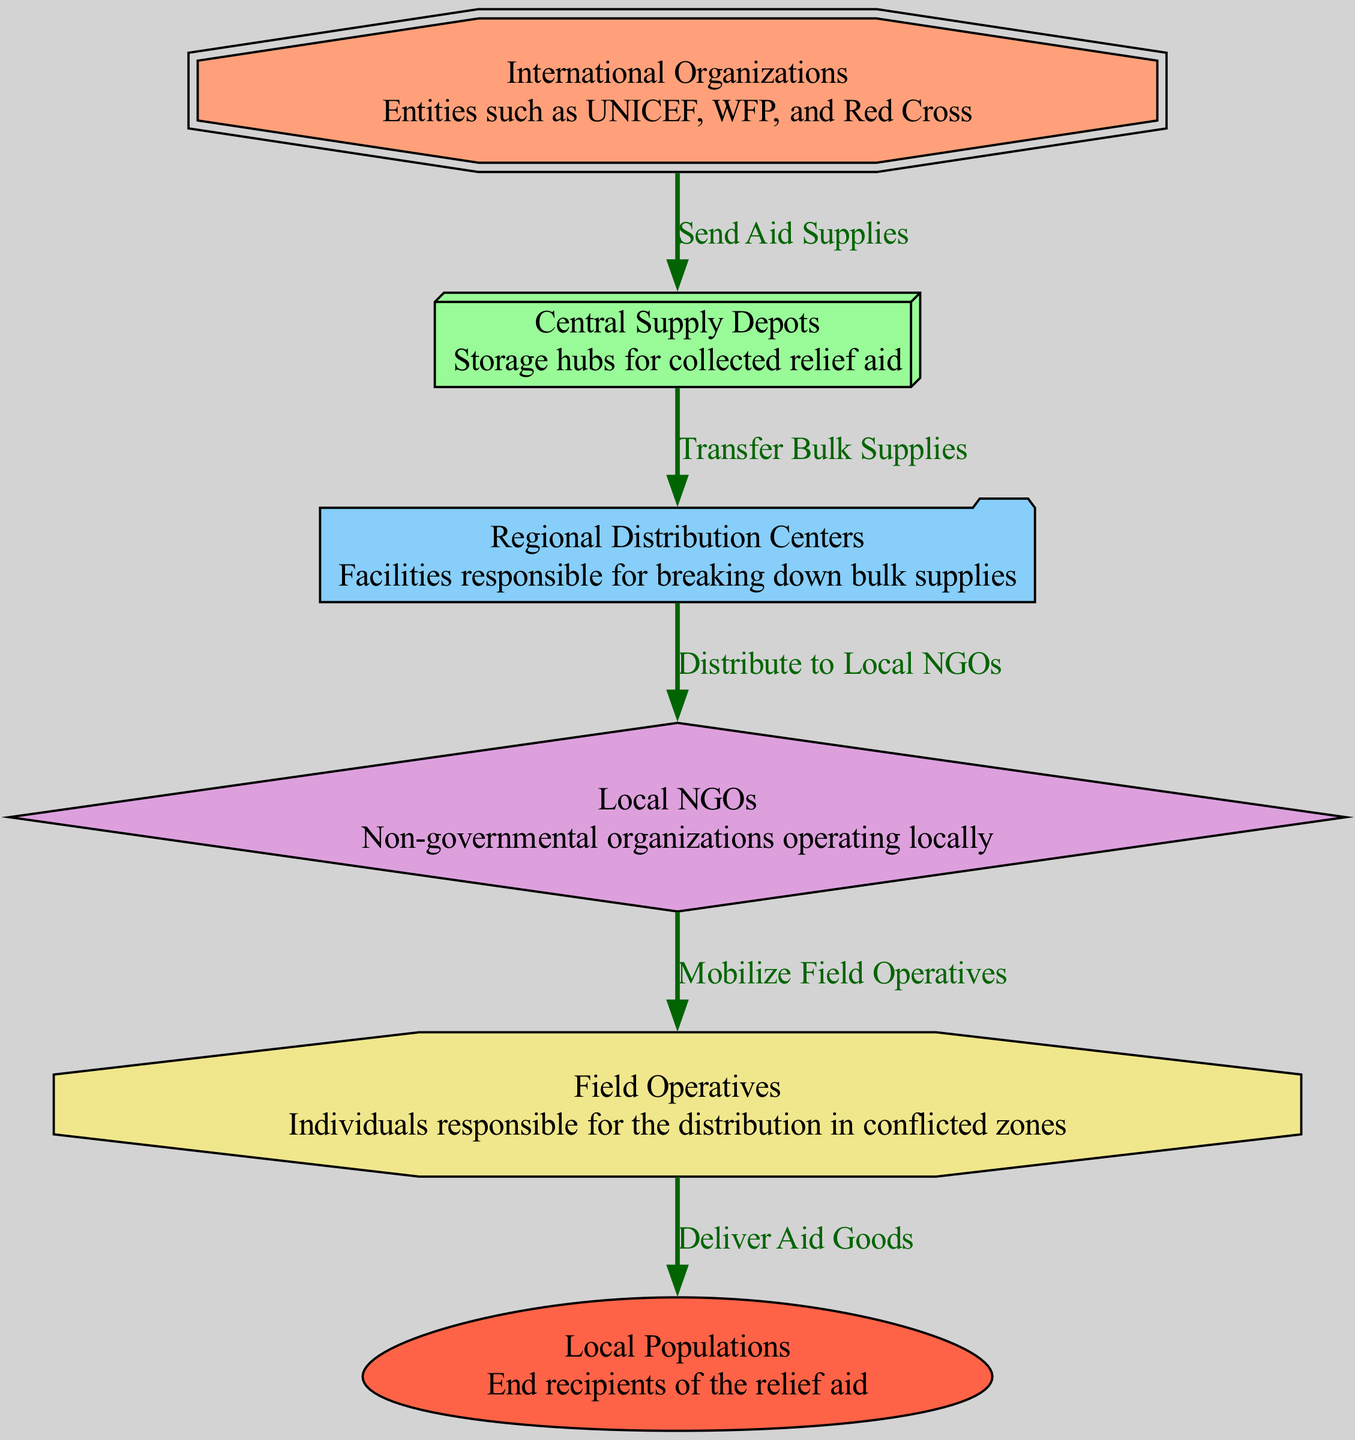What is the starting point for distributing relief aid? The starting point for distributing relief aid is the "International Organizations" node, which indicates where aid supplies are sent from.
Answer: International Organizations How many nodes are present in the diagram? To find the number of nodes, we can count each distinct node listed in the 'nodes' section. In total, there are six nodes identified.
Answer: 6 What is the purpose of Central Supply Depots? The purpose of the "Central Supply Depots" node is to serve as storage hubs for the collected relief aid before it is redistributed.
Answer: Storage hubs for collected relief aid Who mobilizes field operatives? The "Local NGOs" node is responsible for mobilizing field operatives, indicating they play a key role in connecting aid with distribution personnel.
Answer: Local NGOs What type of organization delivers aid goods? The "Field Operatives" node represents the type of organization responsible for delivering aid goods to local populations in the conflict zones.
Answer: Field Operatives Which node is directly connected to the Local Populations? The "Field Operatives" node is directly connected to the "Local Populations," showing the final step in the distribution of relief aid.
Answer: Field Operatives How many edges connect the nodes? By counting the connections listed in the 'edges' section, we can determine there are five edges connecting the nodes in the diagram.
Answer: 5 What role does Regional Distribution Centers play? "Regional Distribution Centers" are facilities responsible for breaking down bulk supplies into smaller quantities for further distribution to local NGOs.
Answer: Breaking down bulk supplies Which node sends aid supplies to Central Supply Depots? The "International Organizations" node is the one that sends aid supplies to the "Central Supply Depots," marking the first step in the relief distribution process.
Answer: International Organizations 